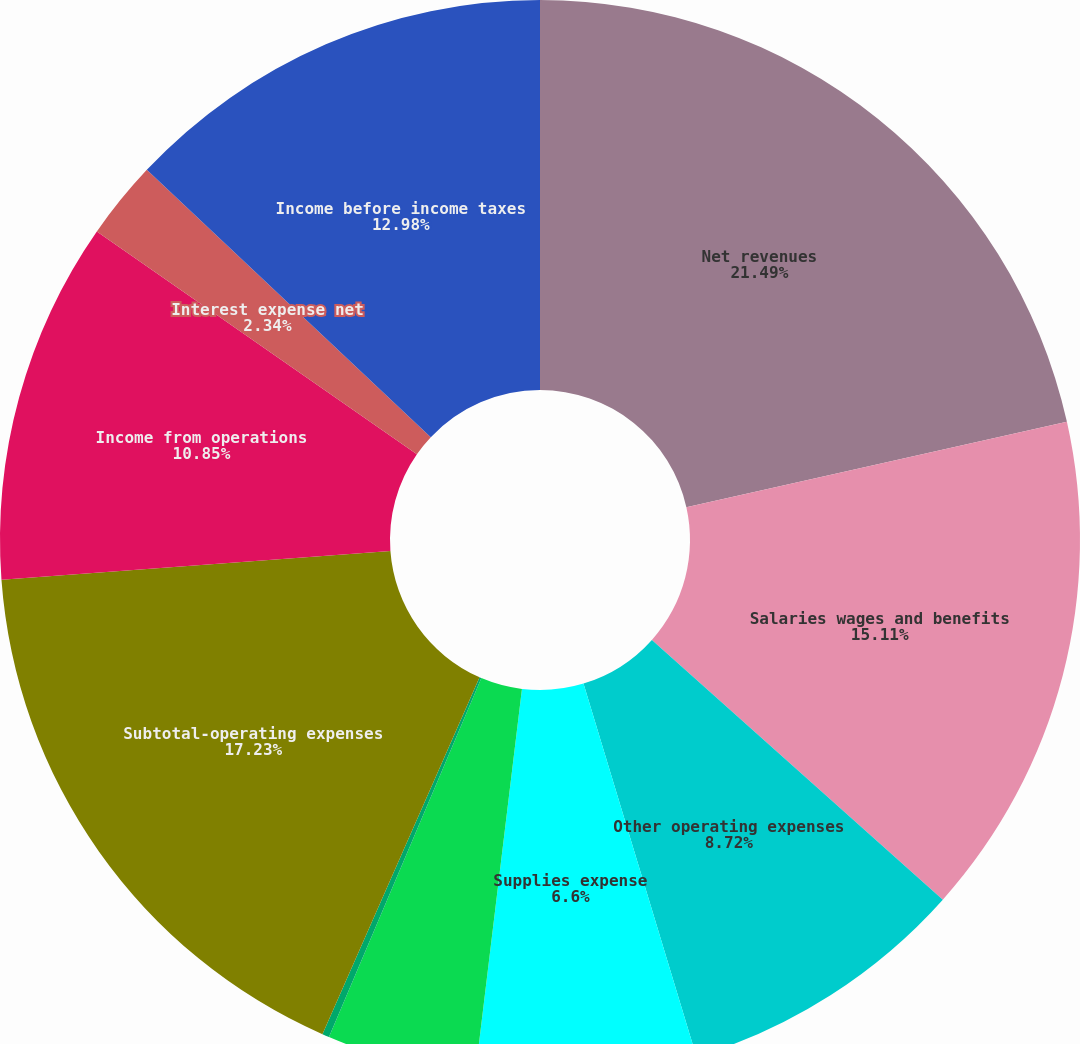Convert chart to OTSL. <chart><loc_0><loc_0><loc_500><loc_500><pie_chart><fcel>Net revenues<fcel>Salaries wages and benefits<fcel>Other operating expenses<fcel>Supplies expense<fcel>Depreciation and amortization<fcel>Lease and rental expense<fcel>Subtotal-operating expenses<fcel>Income from operations<fcel>Interest expense net<fcel>Income before income taxes<nl><fcel>21.49%<fcel>15.11%<fcel>8.72%<fcel>6.6%<fcel>4.47%<fcel>0.21%<fcel>17.23%<fcel>10.85%<fcel>2.34%<fcel>12.98%<nl></chart> 